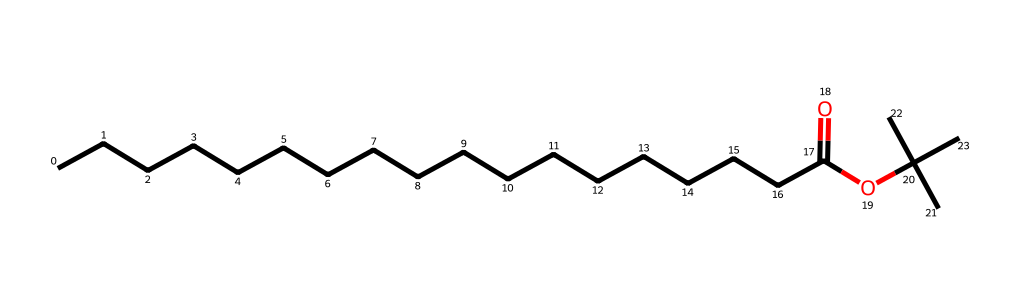What type of functional group is present in this chemical? The chemical structure shows an ester functional group, indicated by the presence of the carbonyl (C=O) adjacent to an oxygen atom bonded to another carbon.
Answer: ester How many carbon atoms are in this molecule? By counting the carbon atoms directly from the SMILES notation, there are 18 carbon atoms total, including those in the carbon chain and the branching.
Answer: eighteen What is the general category of this compound? This chemical is classified as a sealant component, which indicates its application in sealing wax used during the Victorian era.
Answer: wax What is the total number of hydrogen atoms in this molecule? To find the number of hydrogen atoms, we can use the general formula for aliphatic compounds (CnH2n+2), and applying it to this case, we arrive at 36 hydrogen atoms based on the presence of 18 carbon atoms.
Answer: thirty-six Does this chemical contain any nitrogen atoms? By analyzing the structure provided in the SMILES, there are no nitrogen atoms present in this chemical.
Answer: no What is the significance of the branched structure in this chemical? The branched structure contributes to lower melting and boiling points, enhancing its utility in applications such as sealing wax, to ensure it remains pliable at lower temperatures.
Answer: pliable 